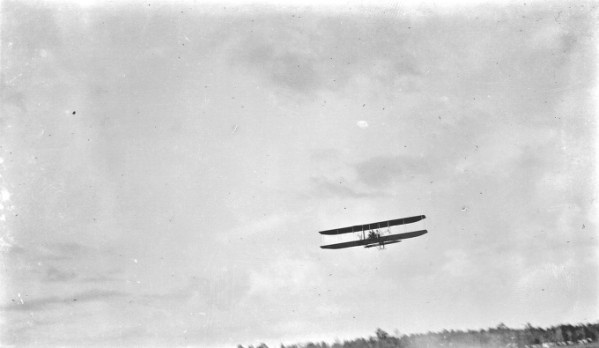Describe the objects in this image and their specific colors. I can see a airplane in white, lightgray, black, gray, and darkgray tones in this image. 